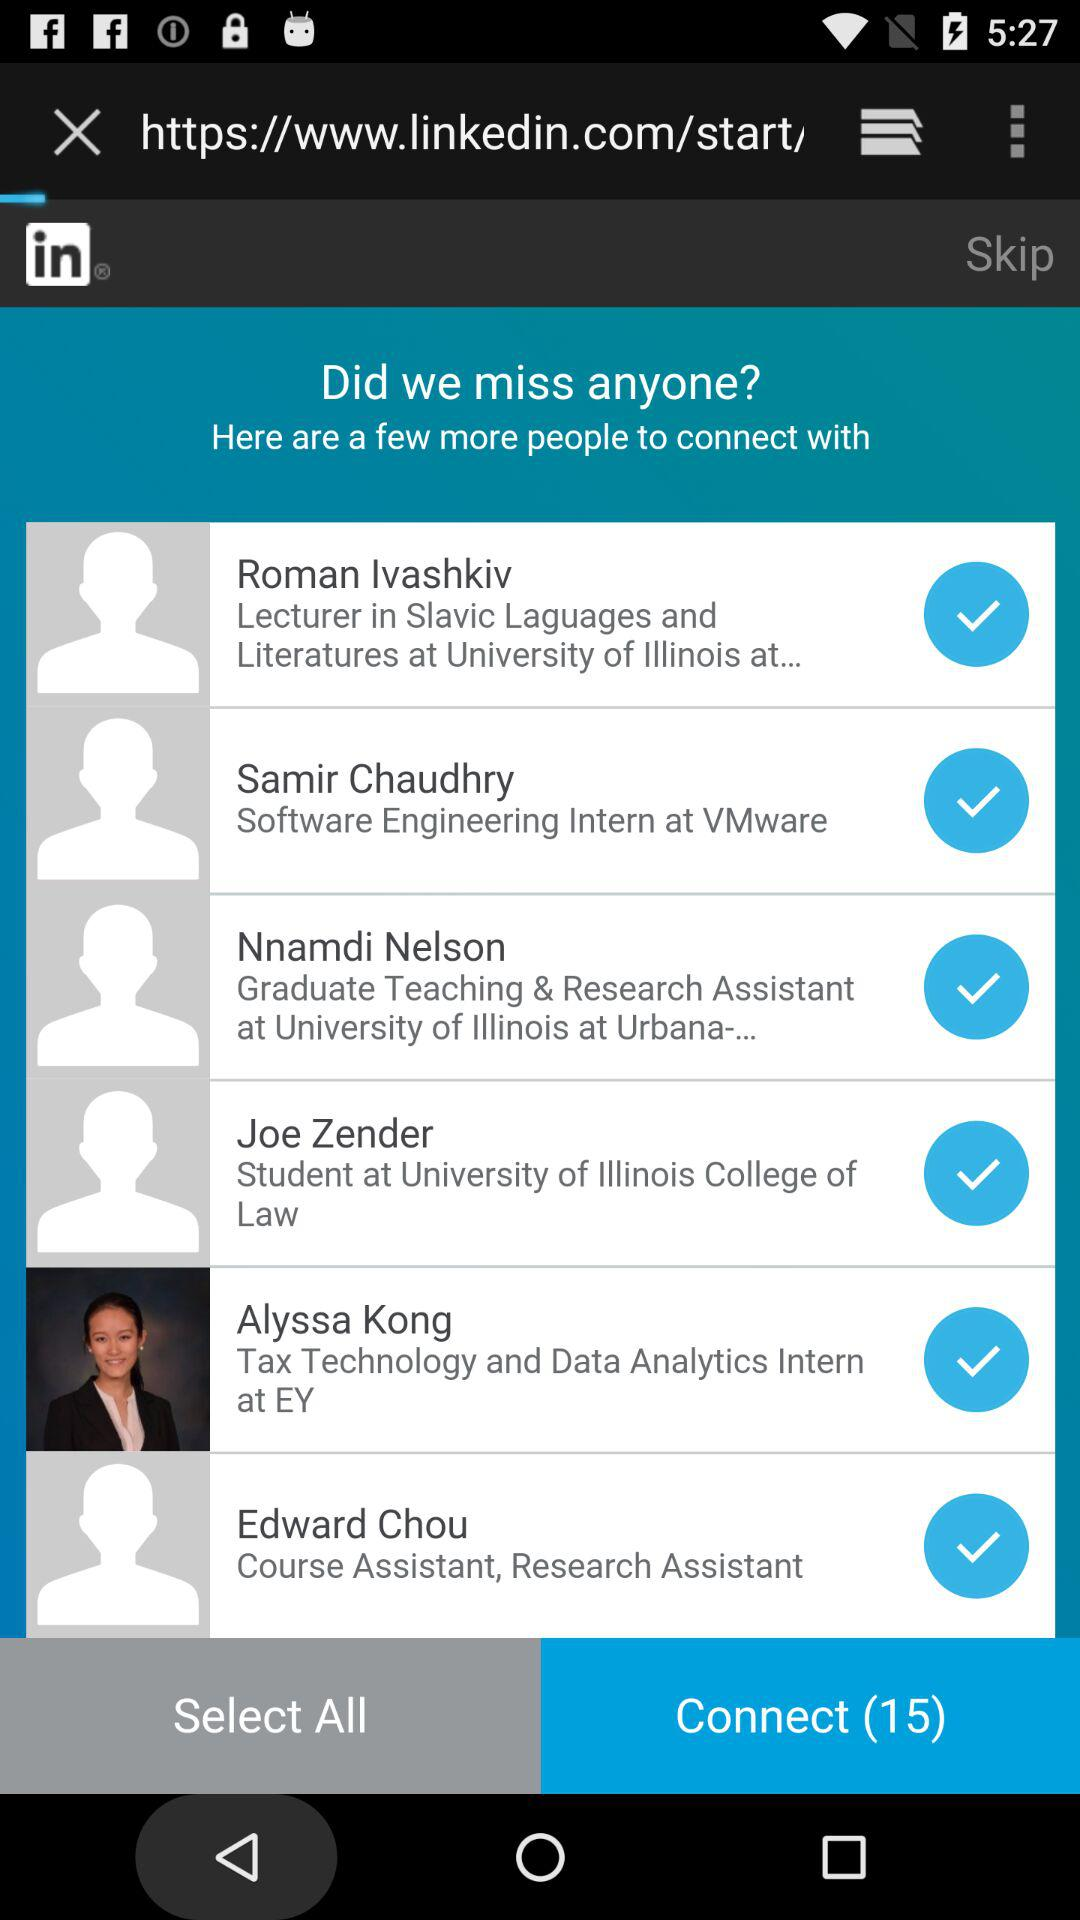How many people are selected to connect with? The number of people that are selected to connect with is 15. 